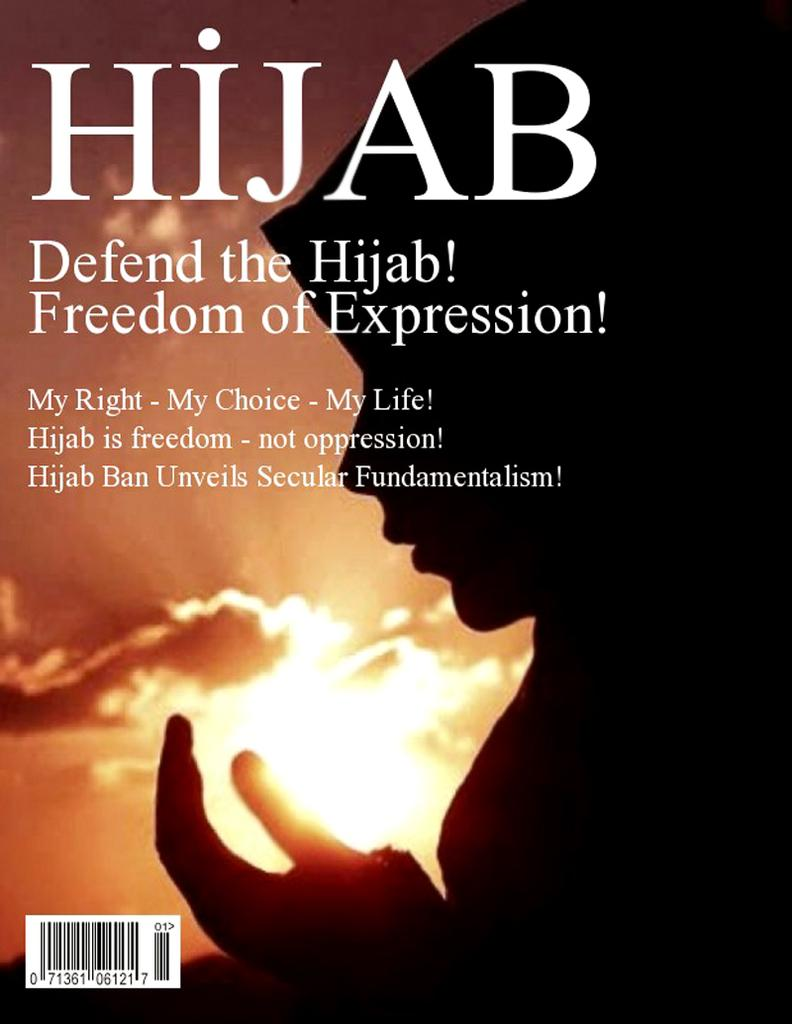<image>
Describe the image concisely. Book cover with woman's profile titled Hijab Defend the Hijab! 